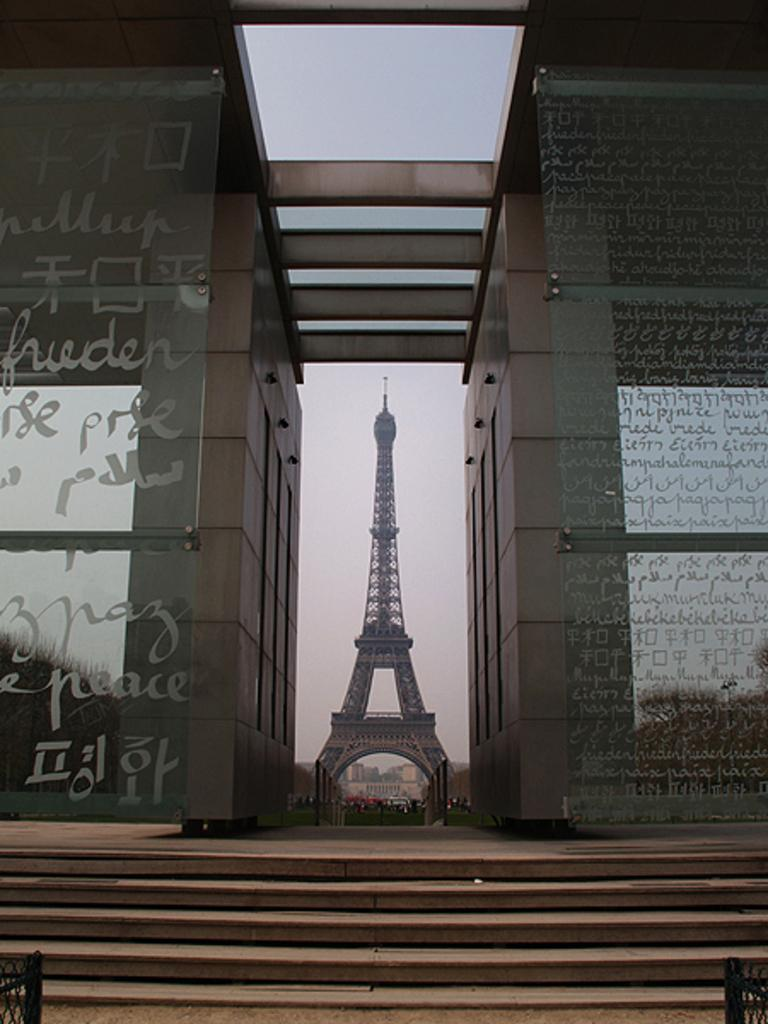What type of walls are present on both the right and left sides of the image? There are glass walls on both the right and left sides of the image. What can be seen at the bottom of the image? There are stairs at the bottom of the image. What is the main structure in the middle of the image? There is a tower in the middle of the image. What is visible in the background of the image? The sky is visible in the background of the image. What type of shoes can be seen on the stage in the image? There is no stage or shoes present in the image. What type of minister is depicted in the image? There is no minister present in the image. 